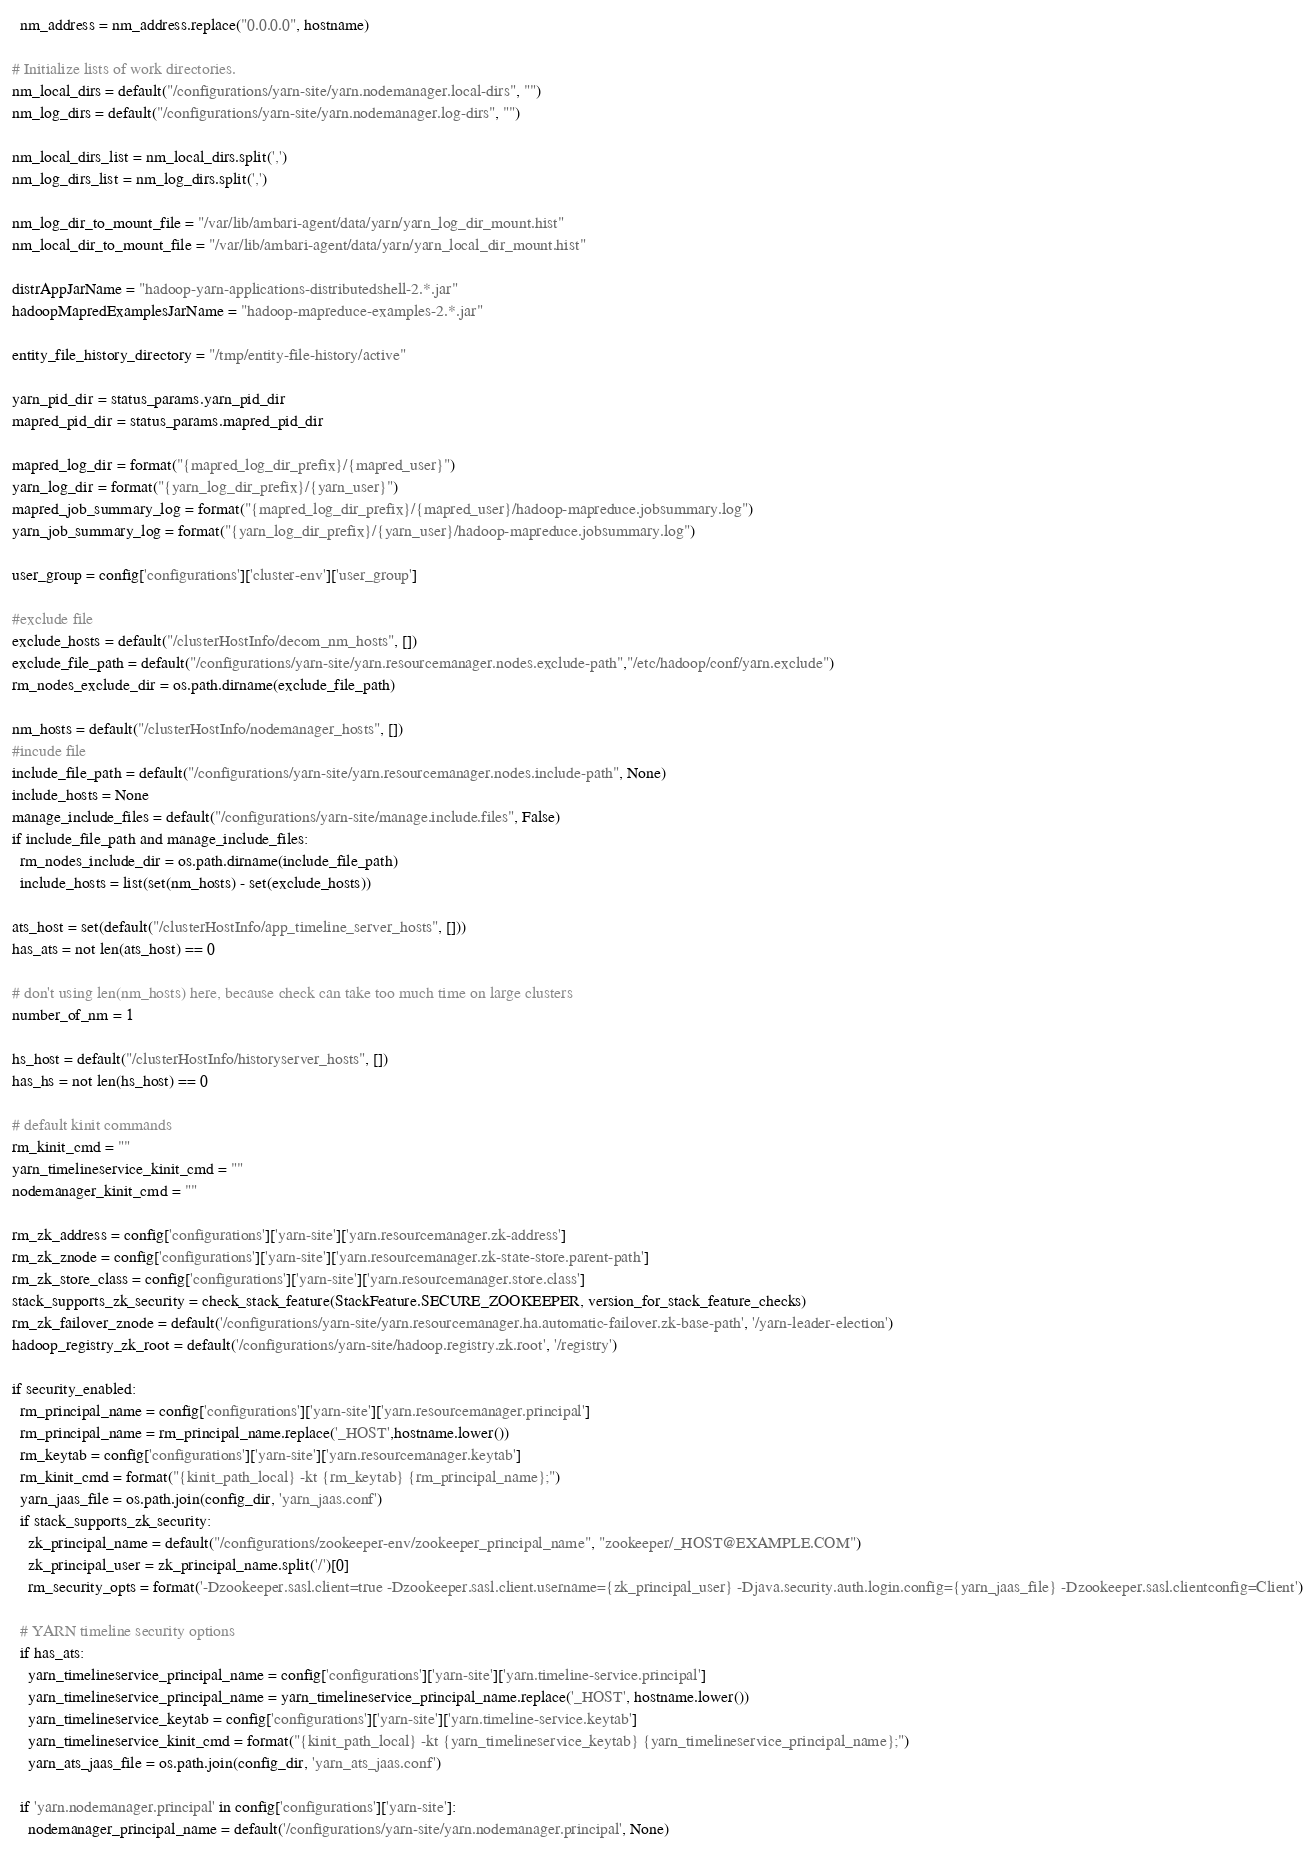Convert code to text. <code><loc_0><loc_0><loc_500><loc_500><_Python_>  nm_address = nm_address.replace("0.0.0.0", hostname)

# Initialize lists of work directories.
nm_local_dirs = default("/configurations/yarn-site/yarn.nodemanager.local-dirs", "")
nm_log_dirs = default("/configurations/yarn-site/yarn.nodemanager.log-dirs", "")

nm_local_dirs_list = nm_local_dirs.split(',')
nm_log_dirs_list = nm_log_dirs.split(',')

nm_log_dir_to_mount_file = "/var/lib/ambari-agent/data/yarn/yarn_log_dir_mount.hist"
nm_local_dir_to_mount_file = "/var/lib/ambari-agent/data/yarn/yarn_local_dir_mount.hist"

distrAppJarName = "hadoop-yarn-applications-distributedshell-2.*.jar"
hadoopMapredExamplesJarName = "hadoop-mapreduce-examples-2.*.jar"

entity_file_history_directory = "/tmp/entity-file-history/active"

yarn_pid_dir = status_params.yarn_pid_dir
mapred_pid_dir = status_params.mapred_pid_dir

mapred_log_dir = format("{mapred_log_dir_prefix}/{mapred_user}")
yarn_log_dir = format("{yarn_log_dir_prefix}/{yarn_user}")
mapred_job_summary_log = format("{mapred_log_dir_prefix}/{mapred_user}/hadoop-mapreduce.jobsummary.log")
yarn_job_summary_log = format("{yarn_log_dir_prefix}/{yarn_user}/hadoop-mapreduce.jobsummary.log")

user_group = config['configurations']['cluster-env']['user_group']

#exclude file
exclude_hosts = default("/clusterHostInfo/decom_nm_hosts", [])
exclude_file_path = default("/configurations/yarn-site/yarn.resourcemanager.nodes.exclude-path","/etc/hadoop/conf/yarn.exclude")
rm_nodes_exclude_dir = os.path.dirname(exclude_file_path)

nm_hosts = default("/clusterHostInfo/nodemanager_hosts", [])
#incude file
include_file_path = default("/configurations/yarn-site/yarn.resourcemanager.nodes.include-path", None)
include_hosts = None
manage_include_files = default("/configurations/yarn-site/manage.include.files", False)
if include_file_path and manage_include_files:
  rm_nodes_include_dir = os.path.dirname(include_file_path)
  include_hosts = list(set(nm_hosts) - set(exclude_hosts))

ats_host = set(default("/clusterHostInfo/app_timeline_server_hosts", []))
has_ats = not len(ats_host) == 0

# don't using len(nm_hosts) here, because check can take too much time on large clusters
number_of_nm = 1

hs_host = default("/clusterHostInfo/historyserver_hosts", [])
has_hs = not len(hs_host) == 0

# default kinit commands
rm_kinit_cmd = ""
yarn_timelineservice_kinit_cmd = ""
nodemanager_kinit_cmd = ""

rm_zk_address = config['configurations']['yarn-site']['yarn.resourcemanager.zk-address']
rm_zk_znode = config['configurations']['yarn-site']['yarn.resourcemanager.zk-state-store.parent-path']
rm_zk_store_class = config['configurations']['yarn-site']['yarn.resourcemanager.store.class']
stack_supports_zk_security = check_stack_feature(StackFeature.SECURE_ZOOKEEPER, version_for_stack_feature_checks)
rm_zk_failover_znode = default('/configurations/yarn-site/yarn.resourcemanager.ha.automatic-failover.zk-base-path', '/yarn-leader-election')
hadoop_registry_zk_root = default('/configurations/yarn-site/hadoop.registry.zk.root', '/registry')

if security_enabled:
  rm_principal_name = config['configurations']['yarn-site']['yarn.resourcemanager.principal']
  rm_principal_name = rm_principal_name.replace('_HOST',hostname.lower())
  rm_keytab = config['configurations']['yarn-site']['yarn.resourcemanager.keytab']
  rm_kinit_cmd = format("{kinit_path_local} -kt {rm_keytab} {rm_principal_name};")
  yarn_jaas_file = os.path.join(config_dir, 'yarn_jaas.conf')
  if stack_supports_zk_security:
    zk_principal_name = default("/configurations/zookeeper-env/zookeeper_principal_name", "zookeeper/_HOST@EXAMPLE.COM")
    zk_principal_user = zk_principal_name.split('/')[0]
    rm_security_opts = format('-Dzookeeper.sasl.client=true -Dzookeeper.sasl.client.username={zk_principal_user} -Djava.security.auth.login.config={yarn_jaas_file} -Dzookeeper.sasl.clientconfig=Client')

  # YARN timeline security options
  if has_ats:
    yarn_timelineservice_principal_name = config['configurations']['yarn-site']['yarn.timeline-service.principal']
    yarn_timelineservice_principal_name = yarn_timelineservice_principal_name.replace('_HOST', hostname.lower())
    yarn_timelineservice_keytab = config['configurations']['yarn-site']['yarn.timeline-service.keytab']
    yarn_timelineservice_kinit_cmd = format("{kinit_path_local} -kt {yarn_timelineservice_keytab} {yarn_timelineservice_principal_name};")
    yarn_ats_jaas_file = os.path.join(config_dir, 'yarn_ats_jaas.conf')

  if 'yarn.nodemanager.principal' in config['configurations']['yarn-site']:
    nodemanager_principal_name = default('/configurations/yarn-site/yarn.nodemanager.principal', None)</code> 